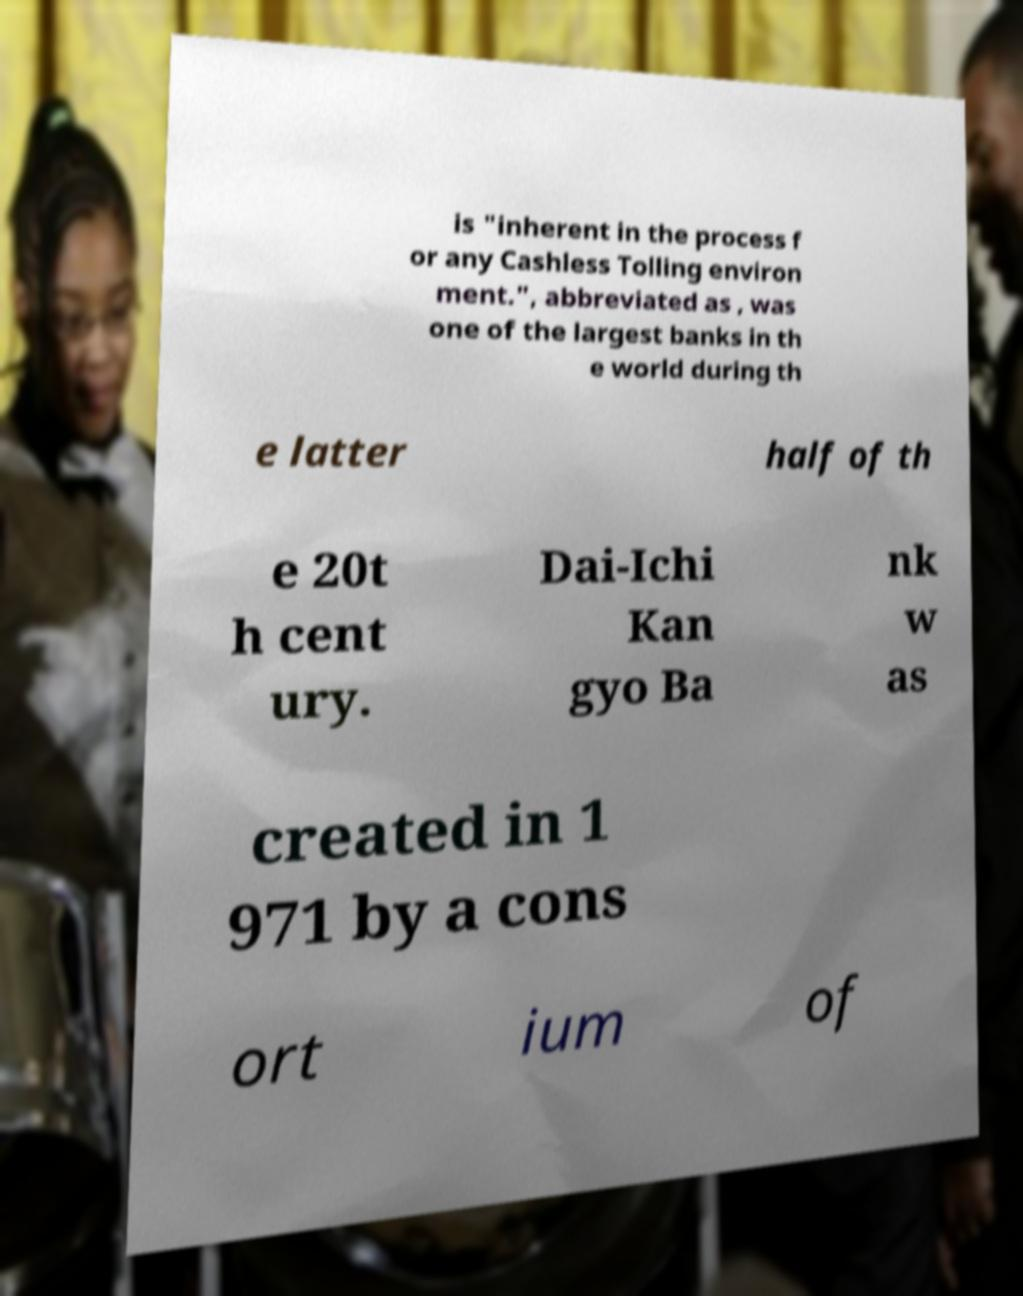Can you accurately transcribe the text from the provided image for me? is "inherent in the process f or any Cashless Tolling environ ment.", abbreviated as , was one of the largest banks in th e world during th e latter half of th e 20t h cent ury. Dai-Ichi Kan gyo Ba nk w as created in 1 971 by a cons ort ium of 